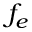Convert formula to latex. <formula><loc_0><loc_0><loc_500><loc_500>f _ { e }</formula> 